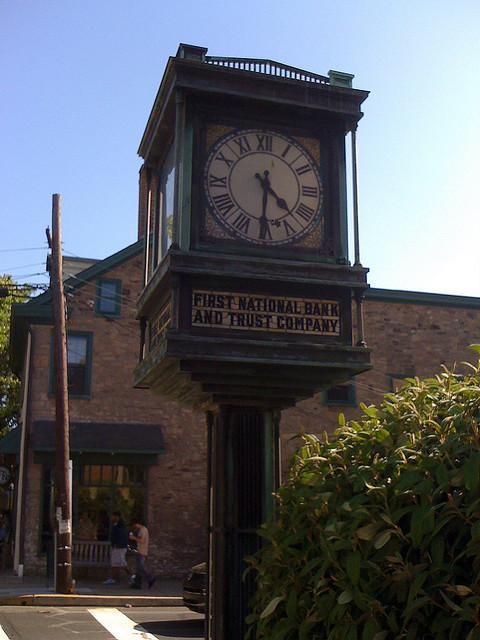How many boats are in the water?
Give a very brief answer. 0. 